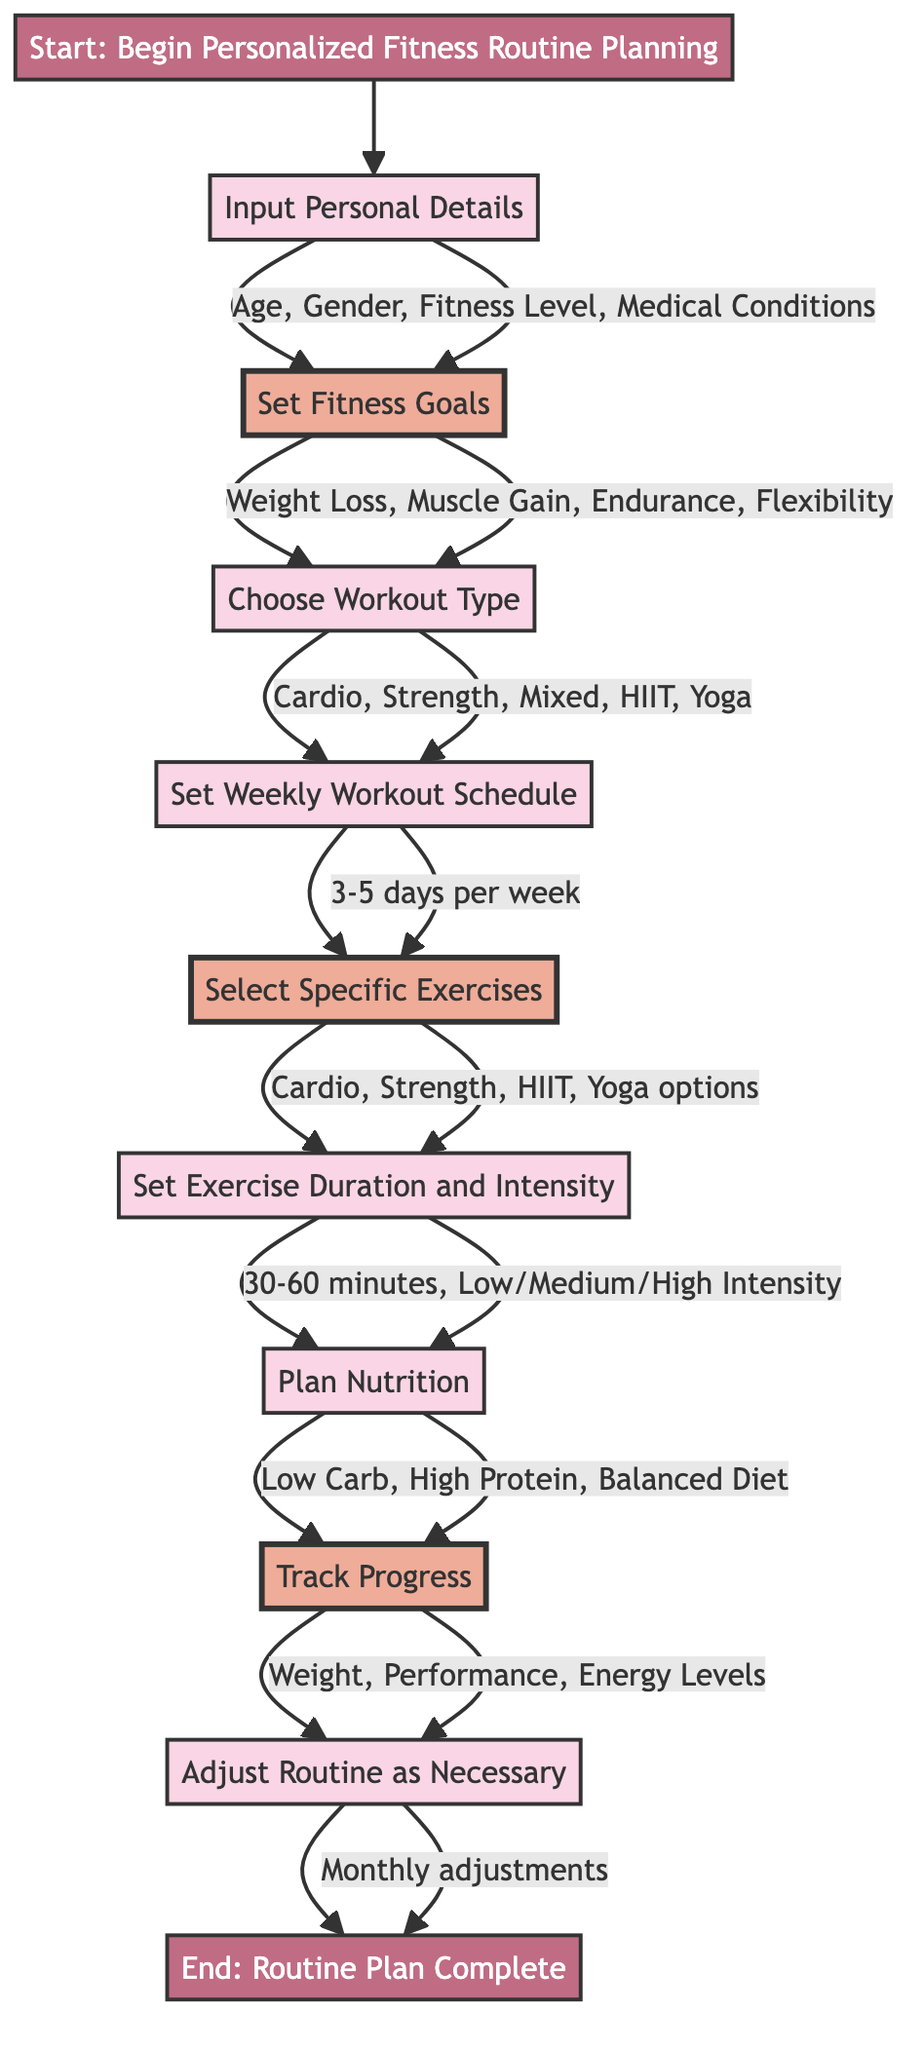What's the starting point of the diagram? The diagram begins with the node labeled "Start: Begin Personalized Fitness Routine Planning," indicating the initial step in the process.
Answer: Start: Begin Personalized Fitness Routine Planning How many different fitness goals can the user set? The diagram lists four types of fitness goals: Weight Loss, Muscle Gain, Endurance, and Flexibility. Therefore, there are four options for setting fitness goals.
Answer: 4 What are the workout types the user can choose from? The diagram provides five options for workout types: Cardio, Strength Training, Mixed Routine, HIIT, and Yoga, which are clearly displayed in the "Choose Workout Type" node.
Answer: Cardio, Strength Training, Mixed Routine, HIIT, Yoga What factors are considered for adjusting the routine? The diagram shows that the adjustment routine considers factors like Plateaus, Goal Changes, and New Preferences. Therefore, these three factors are crucial in making adjustments.
Answer: Plateaus, Goal Changes, New Preferences How frequently will the user track their progress? The diagram specifies that progress will be tracked on a "Weekly" basis, indicating how often the user should assess their fitness journey.
Answer: Weekly After selecting a workout type, what is the next step in the diagram? The diagram flows from "Choose Workout Type" to "Set Weekly Workout Schedule," which is the subsequent step following the workout type selection.
Answer: Set Weekly Workout Schedule What are the categories of exercises the user can select from in the diagram? The diagram categorizes exercises into four types: Cardio Options, Strength Training Options, HIIT Options, and Yoga Options. Therefore, there are four distinct categories for exercise selection.
Answer: Cardio Options, Strength Training Options, HIIT Options, Yoga Options What is the determined duration range for each exercise session? The diagram states that the exercise duration is set between 30 to 60 minutes per session, indicating how long each workout should ideally last.
Answer: 30-60 minutes How often should the user adjust their fitness routine? According to the diagram, the user should adjust their routine on a "Monthly" basis, which highlights the frequency of reviewing and modifying their fitness plan.
Answer: Monthly 